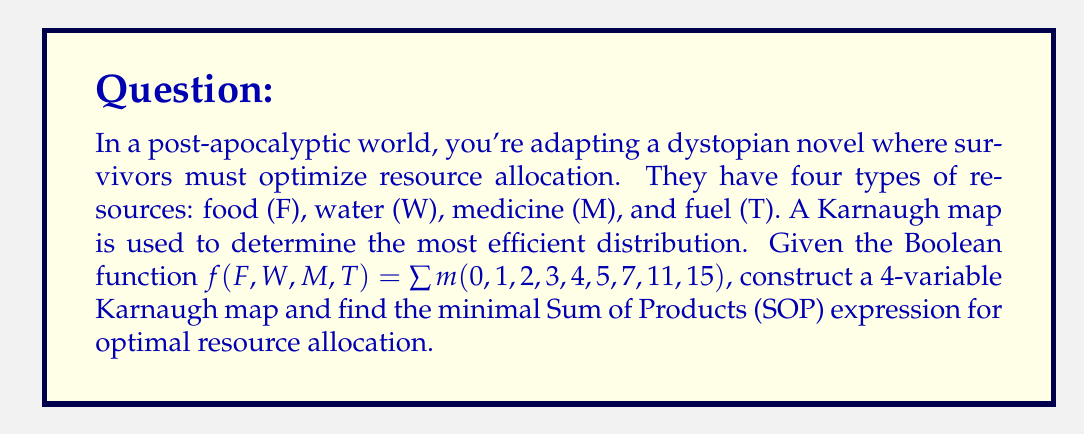Help me with this question. 1. Construct the 4-variable Karnaugh map:

[asy]
unitsize(1cm);
draw((0,0)--(4,0)--(4,4)--(0,4)--cycle);
draw((0,1)--(4,1));
draw((0,2)--(4,2));
draw((0,3)--(4,3));
draw((1,0)--(1,4));
draw((2,0)--(2,4));
draw((3,0)--(3,4));
label("FW$\backslash$MT", (0,4.5));
label("00", (0.5,4.2));
label("01", (1.5,4.2));
label("11", (2.5,4.2));
label("10", (3.5,4.2));
label("00", (-0.5,3.5));
label("01", (-0.5,2.5));
label("11", (-0.5,1.5));
label("10", (-0.5,0.5));
label("1", (0.5,3.5));
label("1", (1.5,3.5));
label("1", (2.5,3.5));
label("1", (3.5,3.5));
label("1", (0.5,2.5));
label("1", (1.5,2.5));
label("0", (2.5,2.5));
label("1", (3.5,2.5));
label("0", (0.5,1.5));
label("0", (1.5,1.5));
label("1", (2.5,1.5));
label("0", (3.5,1.5));
label("0", (0.5,0.5));
label("0", (1.5,0.5));
label("0", (2.5,0.5));
label("1", (3.5,0.5));
[/asy]

2. Identify the largest possible groups of 1's:
   - Group of 8: $\overline{F}\overline{W}$ (top row)
   - Group of 2: $FWT\overline{M}$ (right column, top two cells)
   - Single 1: $FWMT$ (bottom right corner)

3. Write the minimal SOP expression:
   $f(F,W,M,T) = \overline{F}\overline{W} + FWT\overline{M} + FWMT$

4. Simplify if possible:
   The expression is already in its simplest form.

5. Interpret the result:
   - Allocate resources when there's no food and no water ($\overline{F}\overline{W}$)
   - Allocate resources when there's food, water, and fuel, but no medicine ($FWT\overline{M}$)
   - Allocate resources when all four types are available ($FWMT$)
Answer: $f(F,W,M,T) = \overline{F}\overline{W} + FWT\overline{M} + FWMT$ 